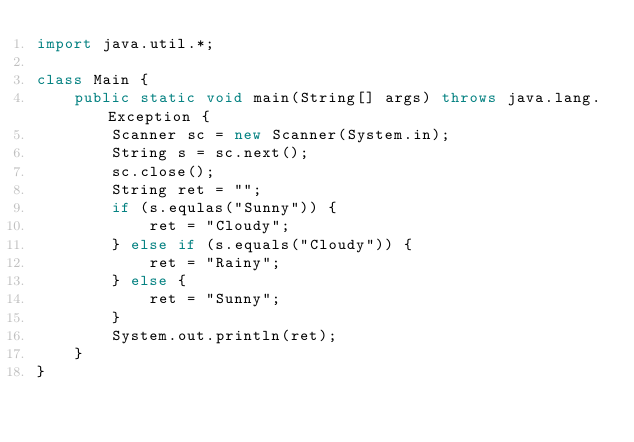Convert code to text. <code><loc_0><loc_0><loc_500><loc_500><_Java_>import java.util.*;

class Main {
    public static void main(String[] args) throws java.lang.Exception {
        Scanner sc = new Scanner(System.in);
        String s = sc.next();
        sc.close();
        String ret = "";
        if (s.equlas("Sunny")) {
            ret = "Cloudy";
        } else if (s.equals("Cloudy")) {
            ret = "Rainy";
        } else {
            ret = "Sunny";
        }
        System.out.println(ret);
    }
}
</code> 